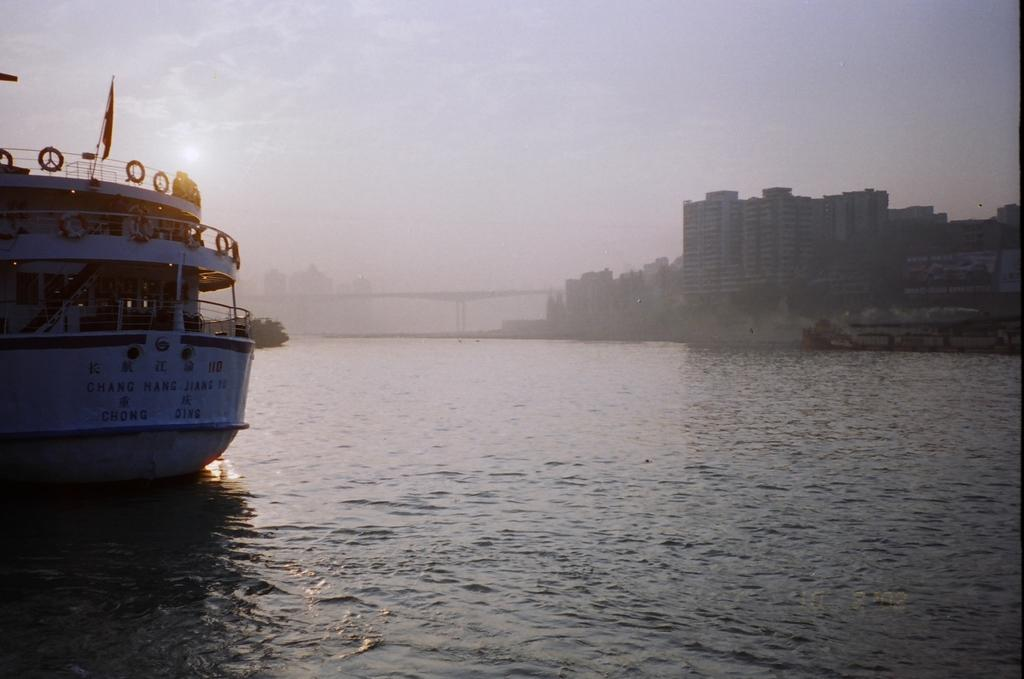What can be seen in the image? There are two ships in the image. Where are the ships located? The ships are on a river. What else is visible in the background of the image? There are buildings and the sky visible in the background of the image. What type of brass instrument is being played on the ships in the image? There is no brass instrument or any indication of music being played in the image. 